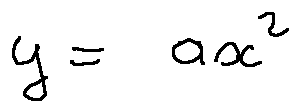<formula> <loc_0><loc_0><loc_500><loc_500>y = a x ^ { 2 }</formula> 